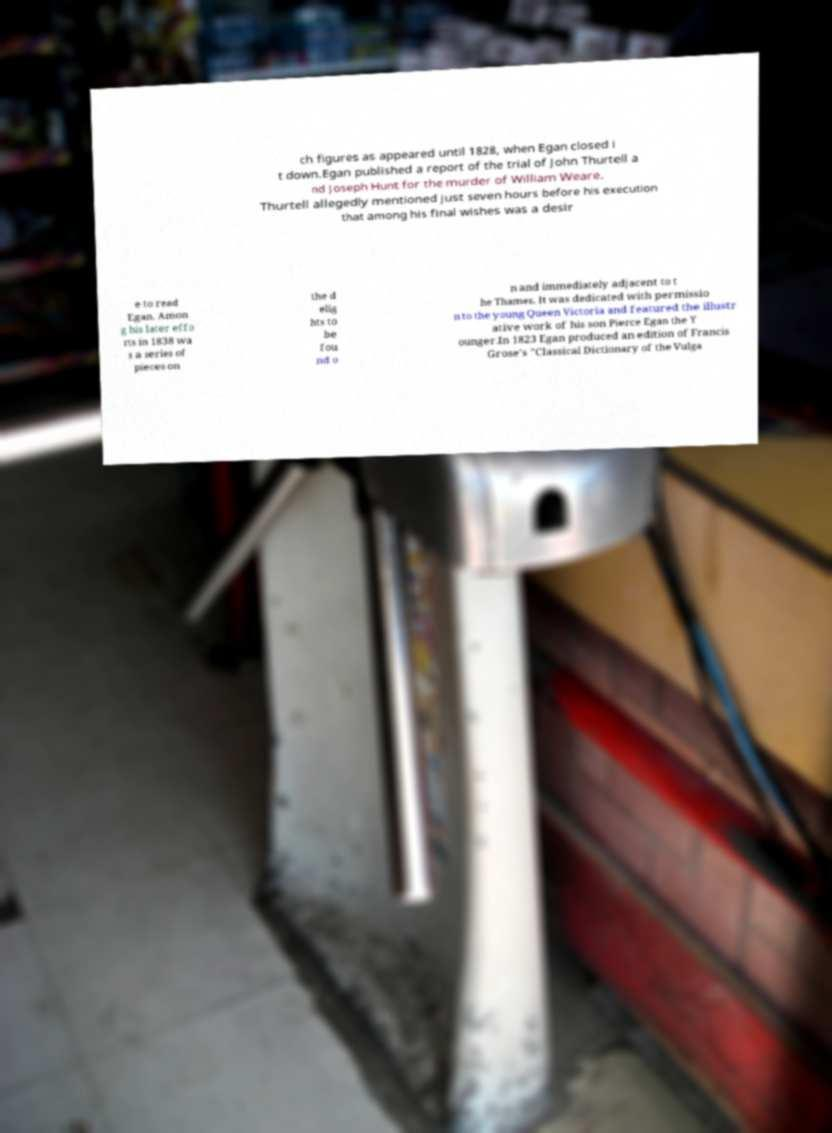I need the written content from this picture converted into text. Can you do that? ch figures as appeared until 1828, when Egan closed i t down.Egan published a report of the trial of John Thurtell a nd Joseph Hunt for the murder of William Weare. Thurtell allegedly mentioned just seven hours before his execution that among his final wishes was a desir e to read Egan. Amon g his later effo rts in 1838 wa s a series of pieces on the d elig hts to be fou nd o n and immediately adjacent to t he Thames. It was dedicated with permissio n to the young Queen Victoria and featured the illustr ative work of his son Pierce Egan the Y ounger.In 1823 Egan produced an edition of Francis Grose's "Classical Dictionary of the Vulga 